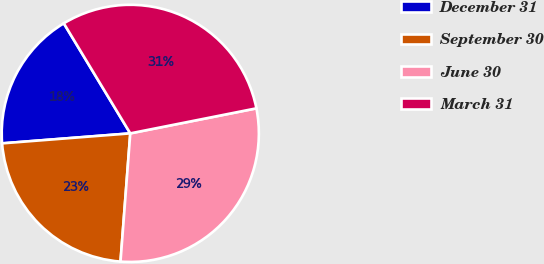Convert chart to OTSL. <chart><loc_0><loc_0><loc_500><loc_500><pie_chart><fcel>December 31<fcel>September 30<fcel>June 30<fcel>March 31<nl><fcel>17.59%<fcel>22.55%<fcel>29.33%<fcel>30.53%<nl></chart> 